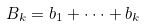Convert formula to latex. <formula><loc_0><loc_0><loc_500><loc_500>B _ { k } = b _ { 1 } + \cdot \cdot \cdot + b _ { k }</formula> 